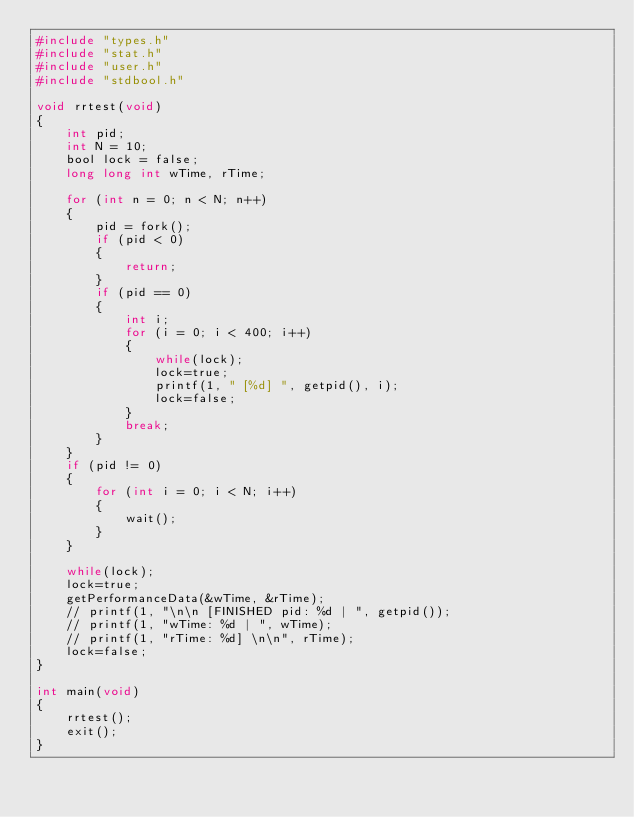Convert code to text. <code><loc_0><loc_0><loc_500><loc_500><_C_>#include "types.h"
#include "stat.h"
#include "user.h"
#include "stdbool.h"

void rrtest(void)
{
    int pid;
    int N = 10;
    bool lock = false;
    long long int wTime, rTime;

    for (int n = 0; n < N; n++)
    {
        pid = fork();
        if (pid < 0)
        {
            return;
        }
        if (pid == 0)
        {
            int i;
            for (i = 0; i < 400; i++)
            {   
                while(lock);
                lock=true;
                printf(1, " [%d] ", getpid(), i);
                lock=false;
            }
            break;
        }
    }
    if (pid != 0)
    {
        for (int i = 0; i < N; i++)
        {
            wait();
        }
    }

    while(lock);
    lock=true;
    getPerformanceData(&wTime, &rTime);
    // printf(1, "\n\n [FINISHED pid: %d | ", getpid());
    // printf(1, "wTime: %d | ", wTime);
    // printf(1, "rTime: %d] \n\n", rTime);
    lock=false;
}

int main(void)
{
    rrtest();
    exit();
}</code> 